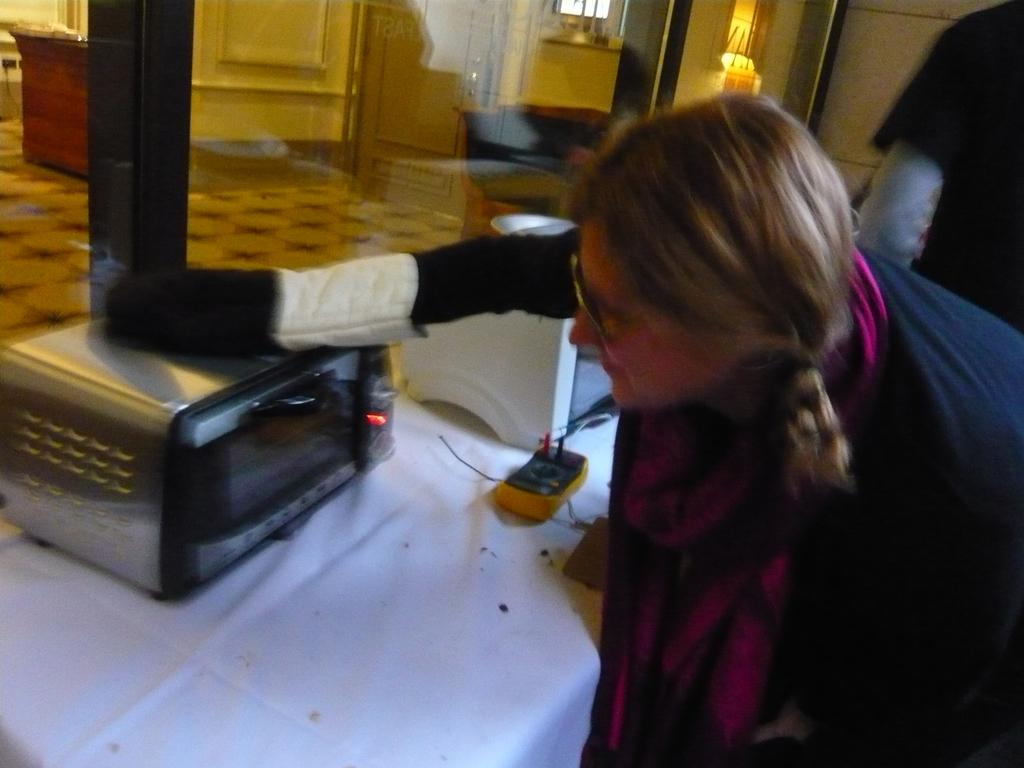Who is present in the picture? There is a woman in the picture. What is on the table in the picture? There are micro ovens on the table. What type of window can be seen in the picture? There is a glass window in the picture. What architectural feature is present on the wall? There is a door on the wall. What advice does the woman give to the plant in the picture? There is no plant present in the picture, so the woman cannot give advice to a plant. 